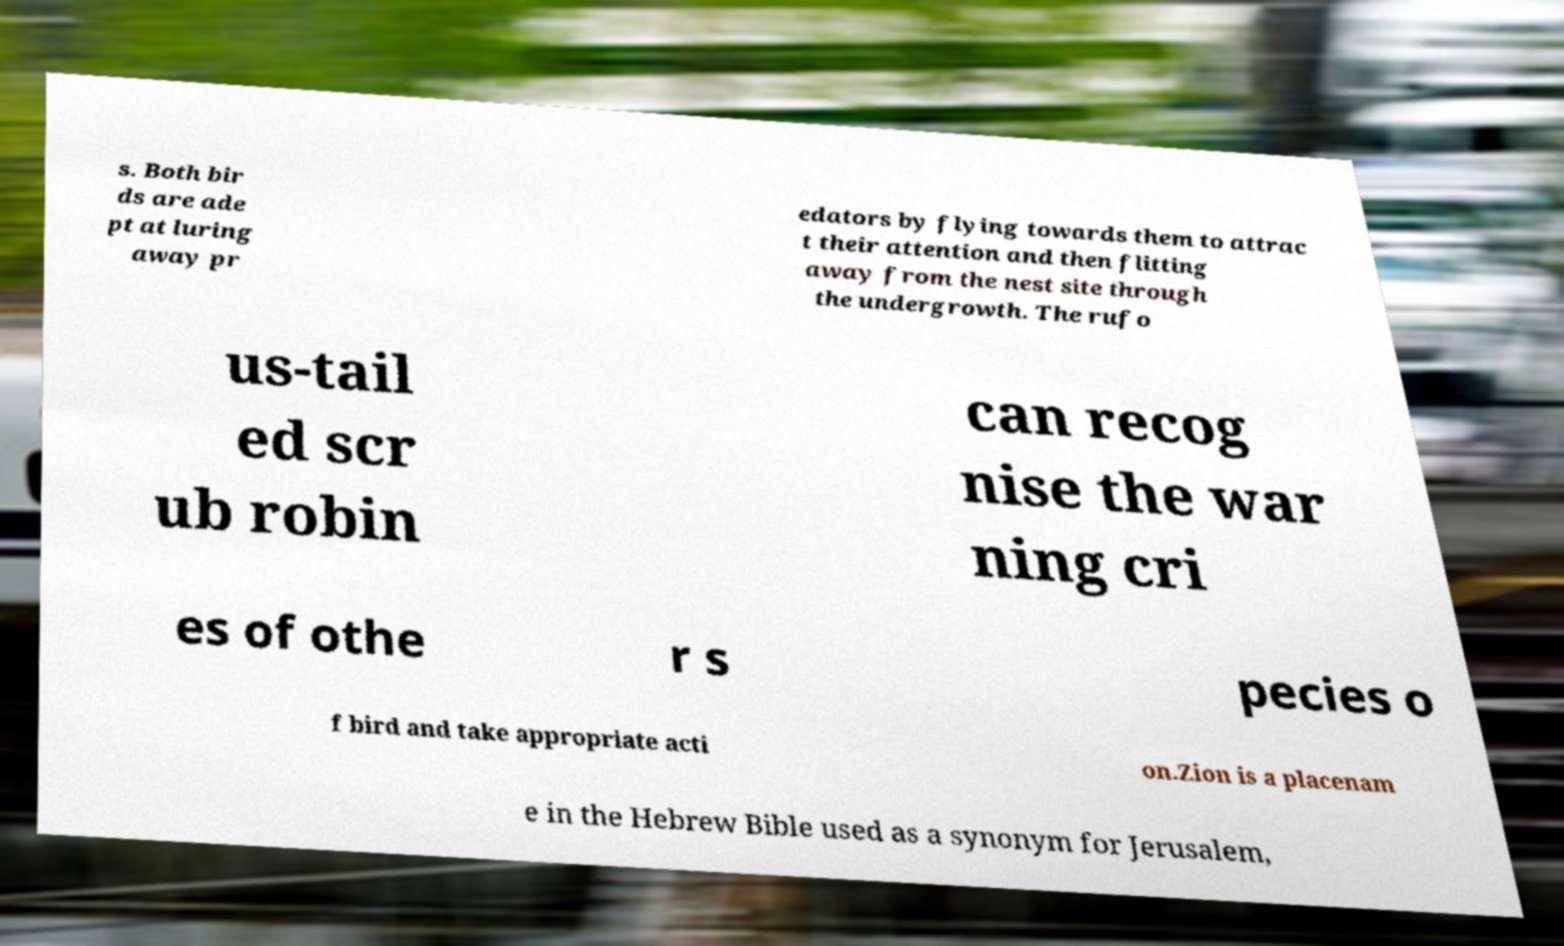Could you assist in decoding the text presented in this image and type it out clearly? s. Both bir ds are ade pt at luring away pr edators by flying towards them to attrac t their attention and then flitting away from the nest site through the undergrowth. The rufo us-tail ed scr ub robin can recog nise the war ning cri es of othe r s pecies o f bird and take appropriate acti on.Zion is a placenam e in the Hebrew Bible used as a synonym for Jerusalem, 